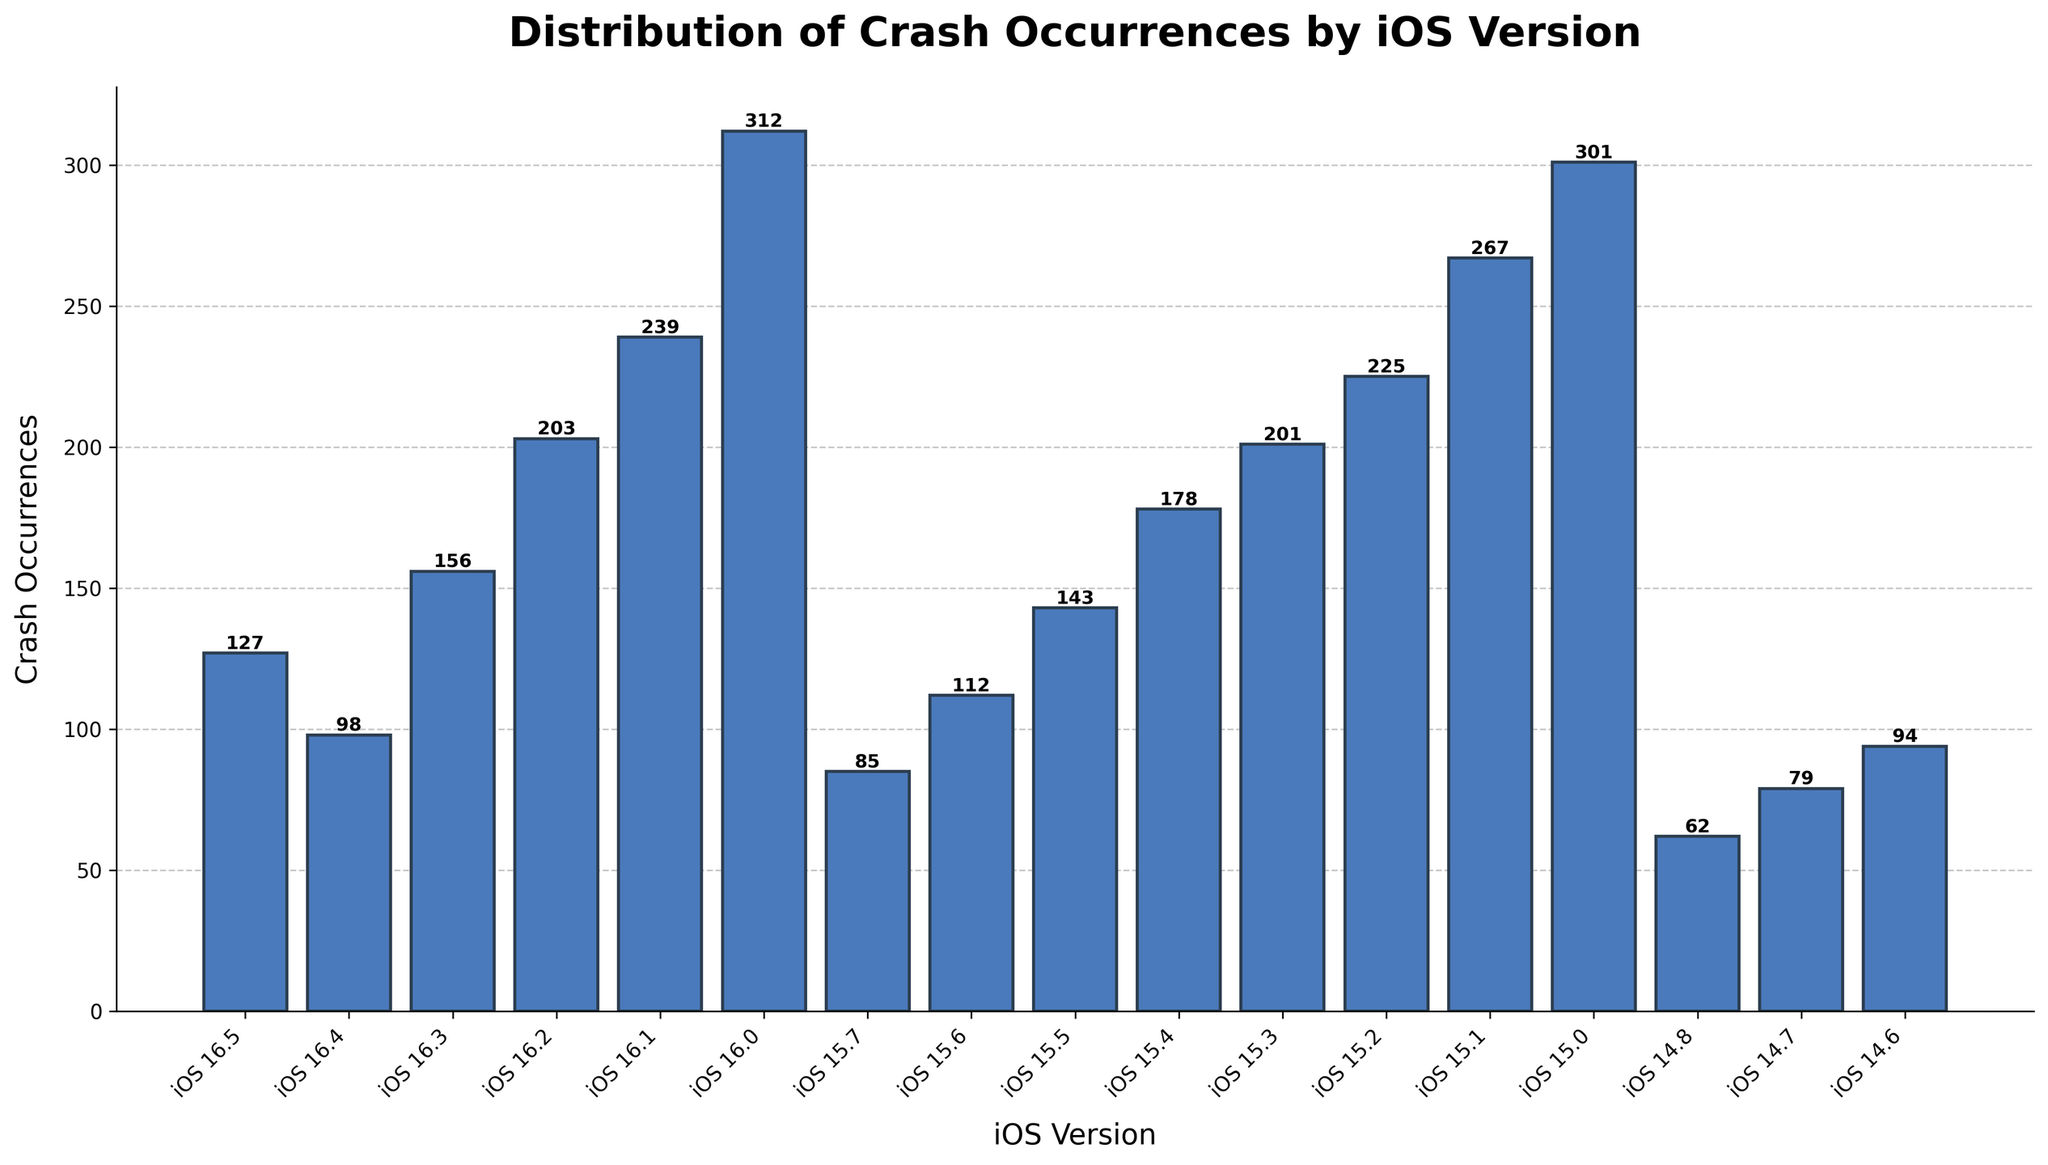Which iOS version has the highest number of crash occurrences? Look for the bar with the greatest height in the bar chart. The highest bar corresponds to the iOS version with the most crashes. In this case, it is iOS 16.0 with 312 occurrences.
Answer: iOS 16.0 Which two iOS versions have the closest number of crash occurrences? Compare the heights and values of the bars for all the iOS versions and find the two bars that are closest in height and number. iOS 16.4 (98) and iOS 14.6 (94) are the closest, with a difference of only 4 crashes.
Answer: iOS 16.4 and iOS 14.6 What is the total number of crash occurrences for all iOS 15 versions combined? Sum the crash occurrences of all iOS 15 versions: 301 + 267 + 225 + 201 + 178 + 143 + 112 + 85 = 1512.
Answer: 1512 How does the number of crashes for iOS 16.0 compare to that of iOS 15.1? Look at the heights of the bars for iOS 16.0 (312) and iOS 15.1 (267), and compare them. iOS 16.0 has more crashes than iOS 15.1.
Answer: iOS 16.0 has more crashes If you averaged the number of crashes for iOS 16.5 and iOS 15.0, what would the average be? Add the crash occurrences for iOS 16.5 (127) and iOS 15.0 (301), then divide by 2 to find the average: (127 + 301) / 2 = 214.
Answer: 214 Which iOS version has fewer crash occurrences: iOS 15.4 or iOS 15.5? Compare the heights of the bars for iOS 15.4 (178) and iOS 15.5 (143). iOS 15.5 has fewer crashes.
Answer: iOS 15.5 